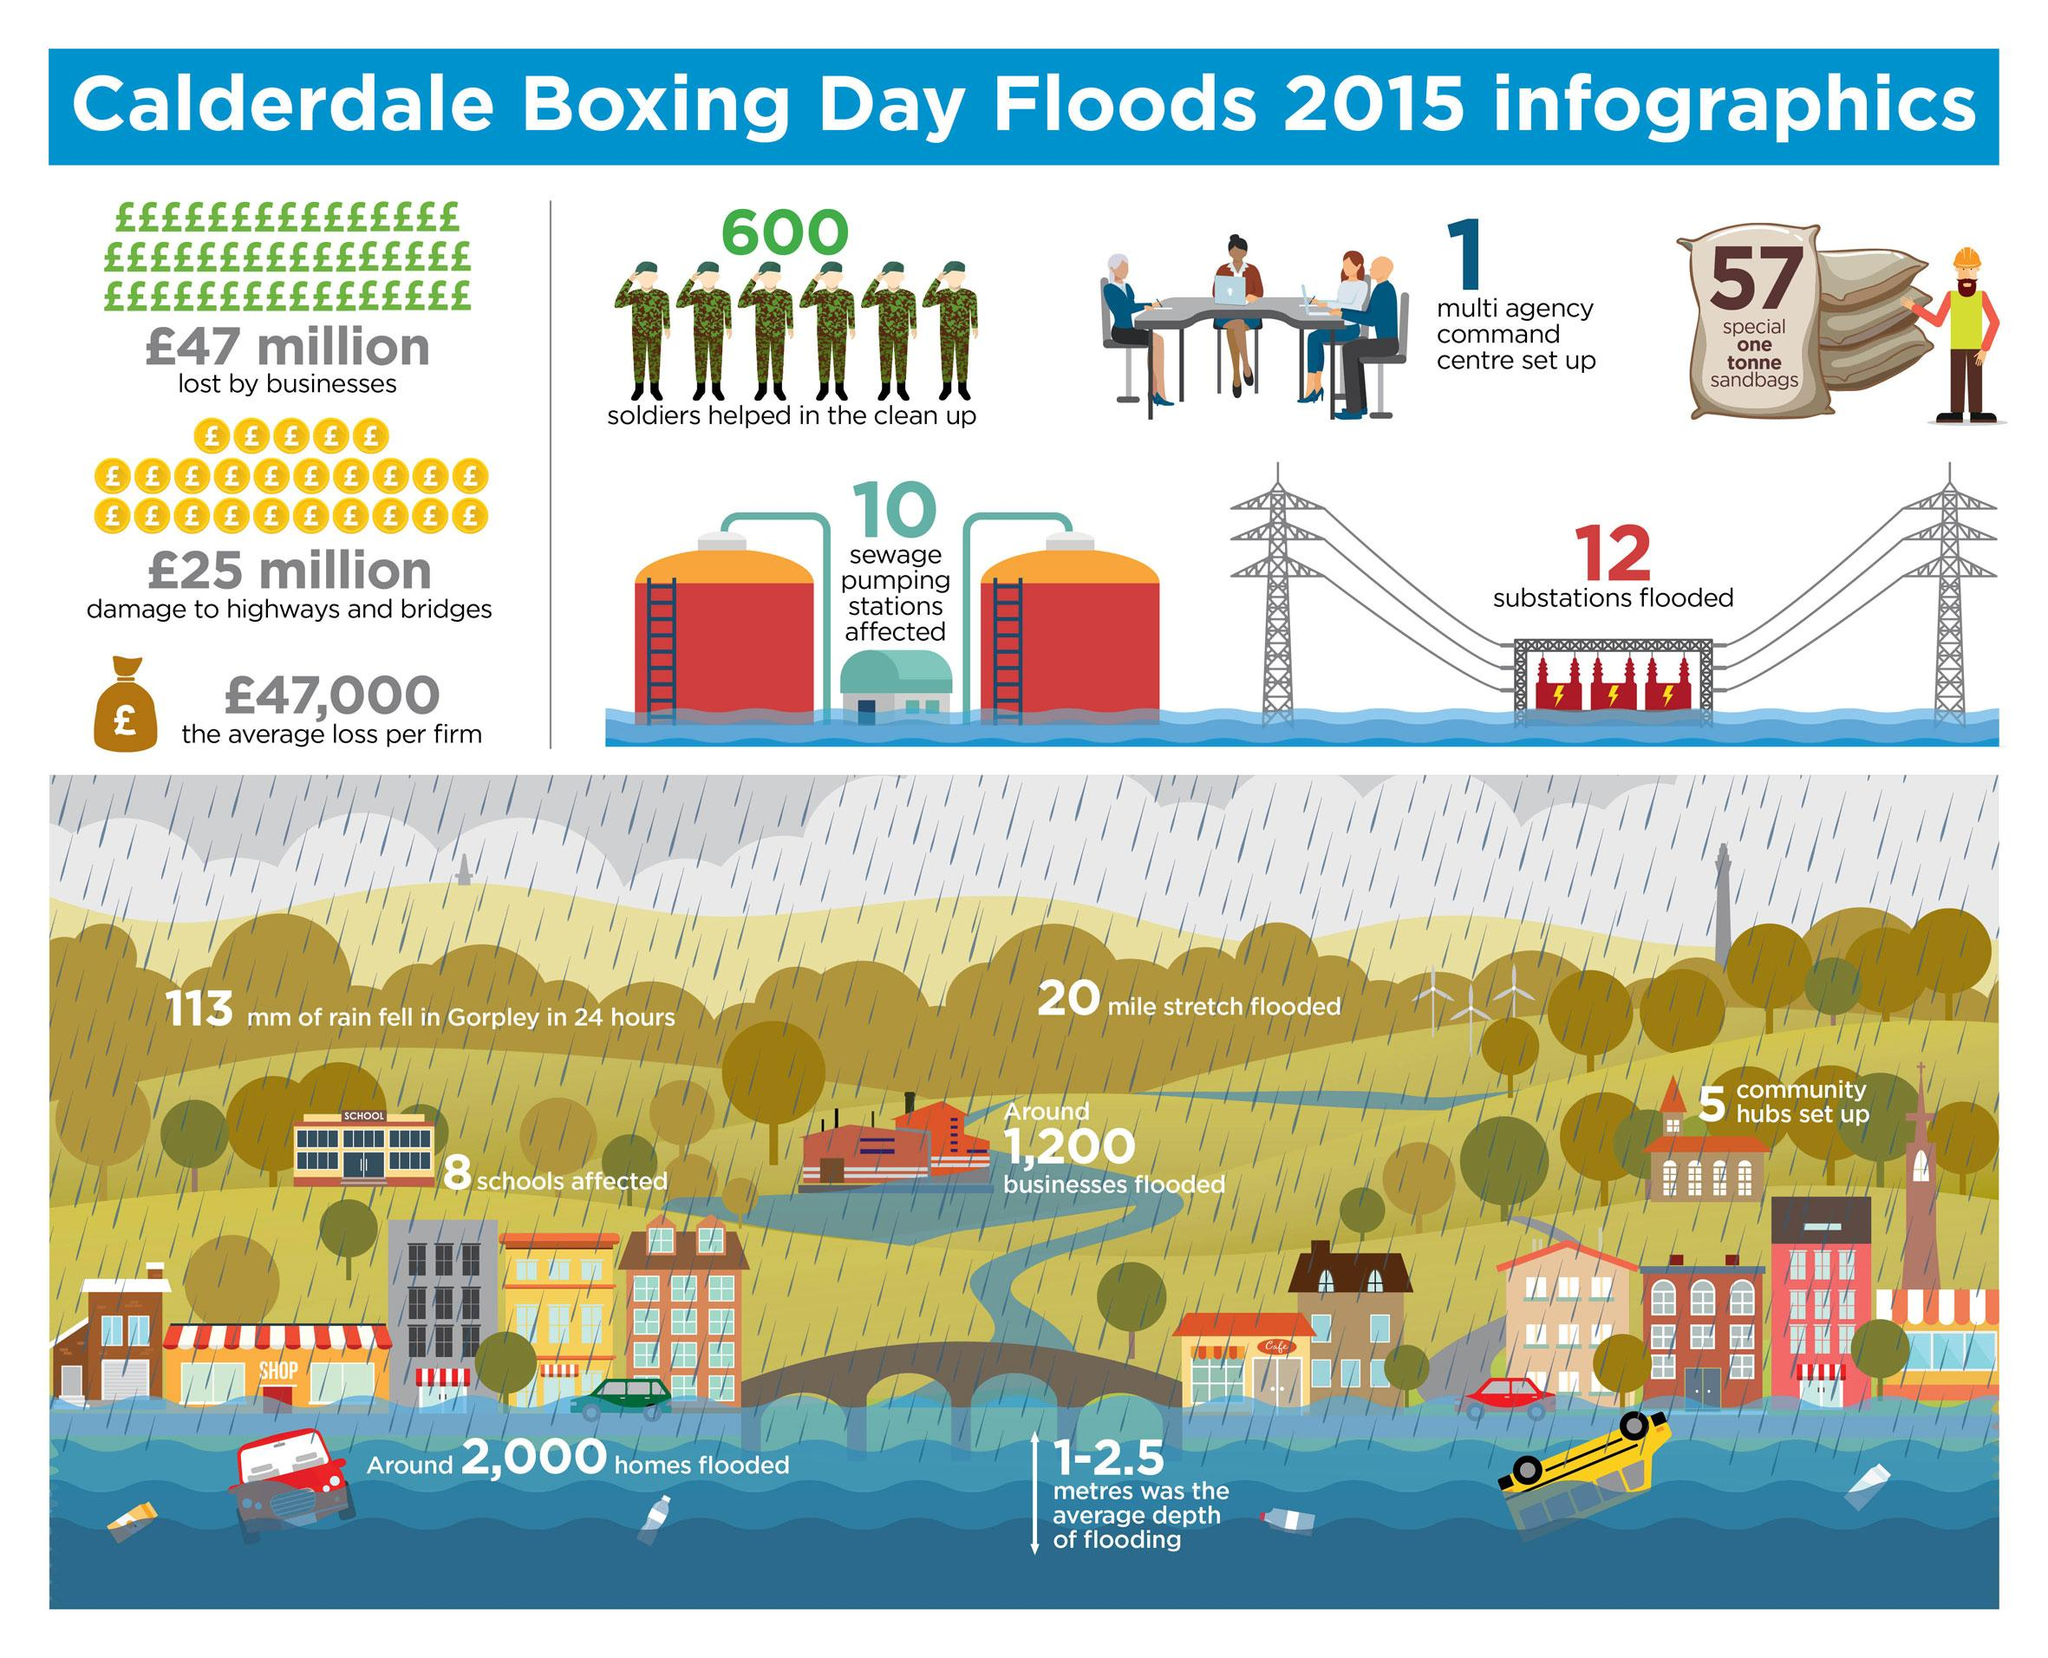Identify some key points in this picture. The flood was cleaned up by 600 soldiers. The average loss per firm was approximately £47,000. During the recent flood, 10 sewage pumping stations were affected, disrupting the proper disposal of wastewater in the affected areas. Approximately 1,200 businesses were flooded. We established one multi-agency command center. 